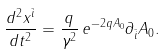Convert formula to latex. <formula><loc_0><loc_0><loc_500><loc_500>\frac { d ^ { 2 } x ^ { \bar { i } } } { d t ^ { 2 } } = \frac { q } { \gamma ^ { 2 } } \, e ^ { - 2 q A _ { 0 } } \partial _ { \bar { i } } A _ { 0 } .</formula> 